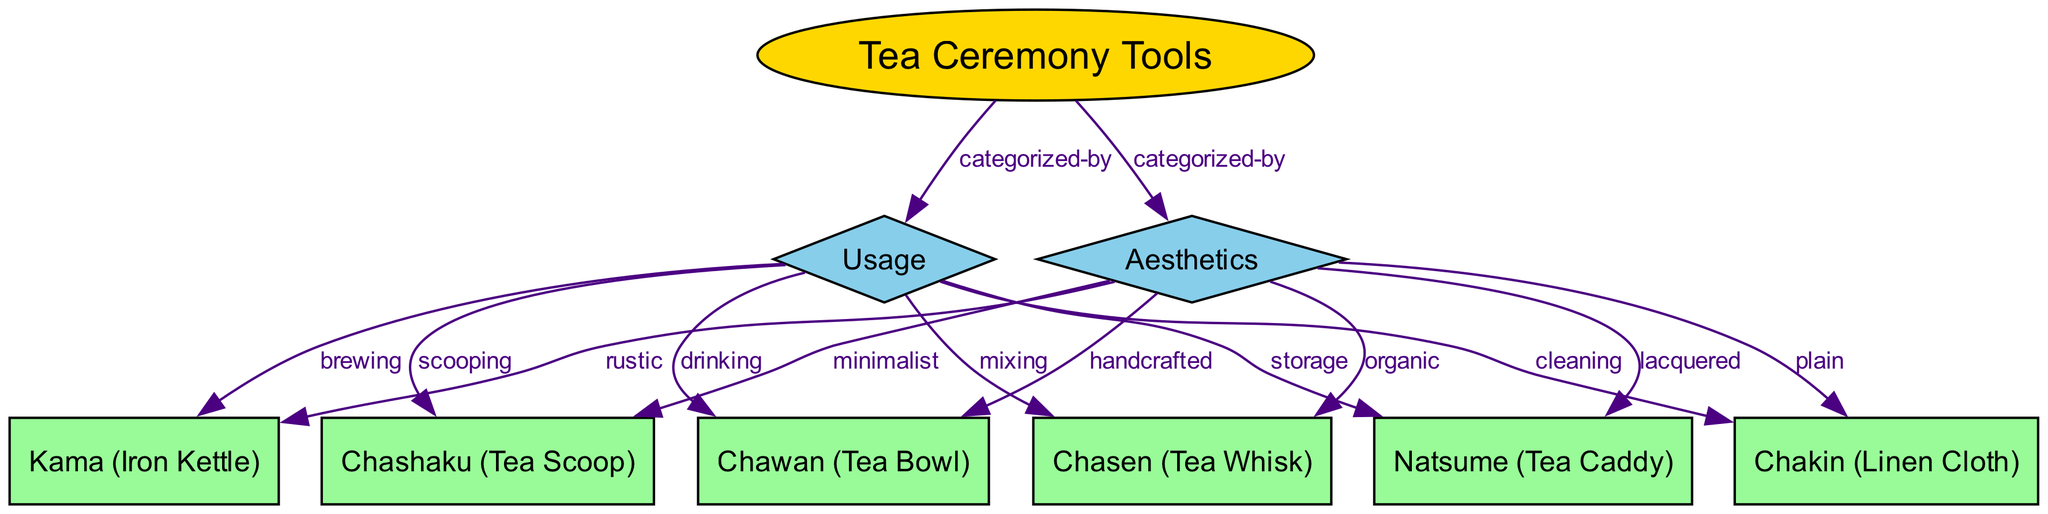What is the main root node of the diagram? The root node is labeled "Tea Ceremony Tools," which serves as the primary category under which all other elements are organized.
Answer: Tea Ceremony Tools How many tools are listed in the diagram? There are six tools displayed in the diagram: Kama, Chawan, Chasen, Natsume, Chashaku, and Chakin. Counting these nodes gives a total of six.
Answer: 6 What is the usage categorization for the Chawan tool? The Chawan tool is categorized under "drinking" according to the edge connection.
Answer: drinking Which attribute is connected to the Kama tool? The Kama tool is associated with the "brewing" usage category as indicated by the edge that connects them.
Answer: brewing What aesthetic is linked with the Chasen tool? The Chasen tool is described as "organic," which is the label of the edge connecting it with the Aesthetics attribute.
Answer: organic How many edges connect to the Aesthetics attribute? There are six edges that connect the Aesthetics attribute to various tools, indicating multiple aesthetic qualities associated with different tools.
Answer: 6 Which tool is categorized as "minimalist"? The Chashaku tool has the label "minimalist" connecting it to the Aesthetics attribute, indicating its design style.
Answer: Chashaku What type of relationship do the edges represent in this diagram? The edges represent categorization relationships, showing how tools are categorized by their usage and aesthetic through labels on the edges.
Answer: categorized-by What are the two main attributes in the diagram? The two main attributes in the diagram are "Usage" and "Aesthetics," both of which categorize the tools accordingly.
Answer: Usage and Aesthetics 